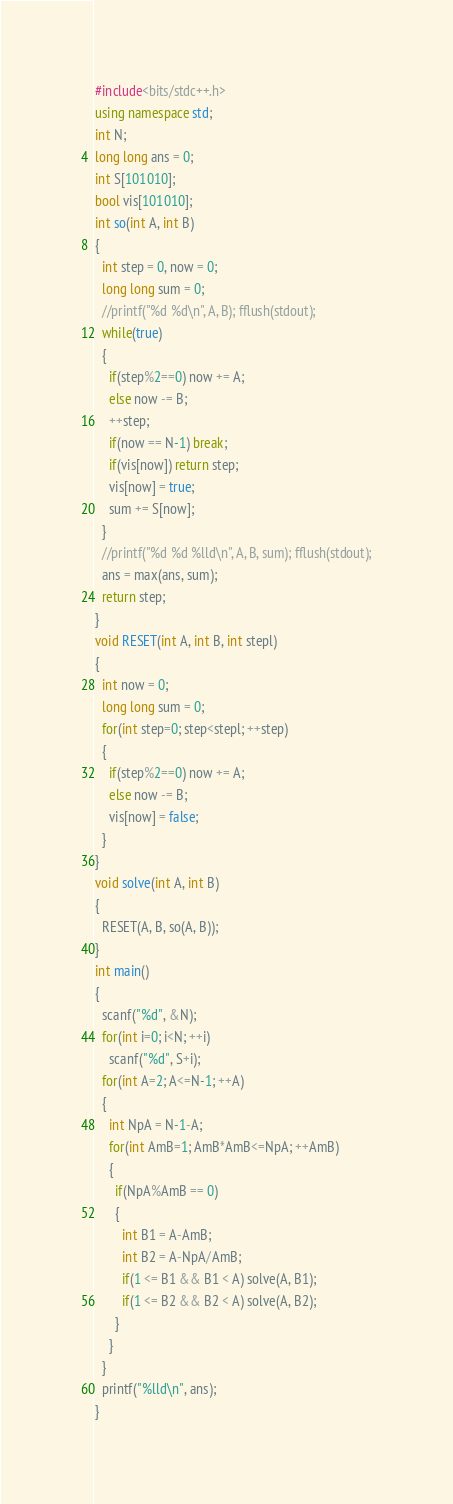Convert code to text. <code><loc_0><loc_0><loc_500><loc_500><_C++_>#include<bits/stdc++.h>
using namespace std;
int N;
long long ans = 0;
int S[101010];
bool vis[101010];
int so(int A, int B)
{
  int step = 0, now = 0;
  long long sum = 0;
  //printf("%d %d\n", A, B); fflush(stdout);
  while(true)
  {
    if(step%2==0) now += A;
    else now -= B;
    ++step;
    if(now == N-1) break;
    if(vis[now]) return step;
    vis[now] = true;
    sum += S[now];
  }
  //printf("%d %d %lld\n", A, B, sum); fflush(stdout);
  ans = max(ans, sum);
  return step;
}
void RESET(int A, int B, int stepl)
{
  int now = 0;
  long long sum = 0;
  for(int step=0; step<stepl; ++step)
  {
    if(step%2==0) now += A;
    else now -= B;
    vis[now] = false;
  }
}
void solve(int A, int B)
{
  RESET(A, B, so(A, B));  
}
int main()
{
  scanf("%d", &N);
  for(int i=0; i<N; ++i)
    scanf("%d", S+i);
  for(int A=2; A<=N-1; ++A)
  {
    int NpA = N-1-A;
    for(int AmB=1; AmB*AmB<=NpA; ++AmB)
    {
      if(NpA%AmB == 0)
      {
        int B1 = A-AmB;
        int B2 = A-NpA/AmB;
        if(1 <= B1 && B1 < A) solve(A, B1);
        if(1 <= B2 && B2 < A) solve(A, B2);
      }
    }
  }
  printf("%lld\n", ans);
}</code> 